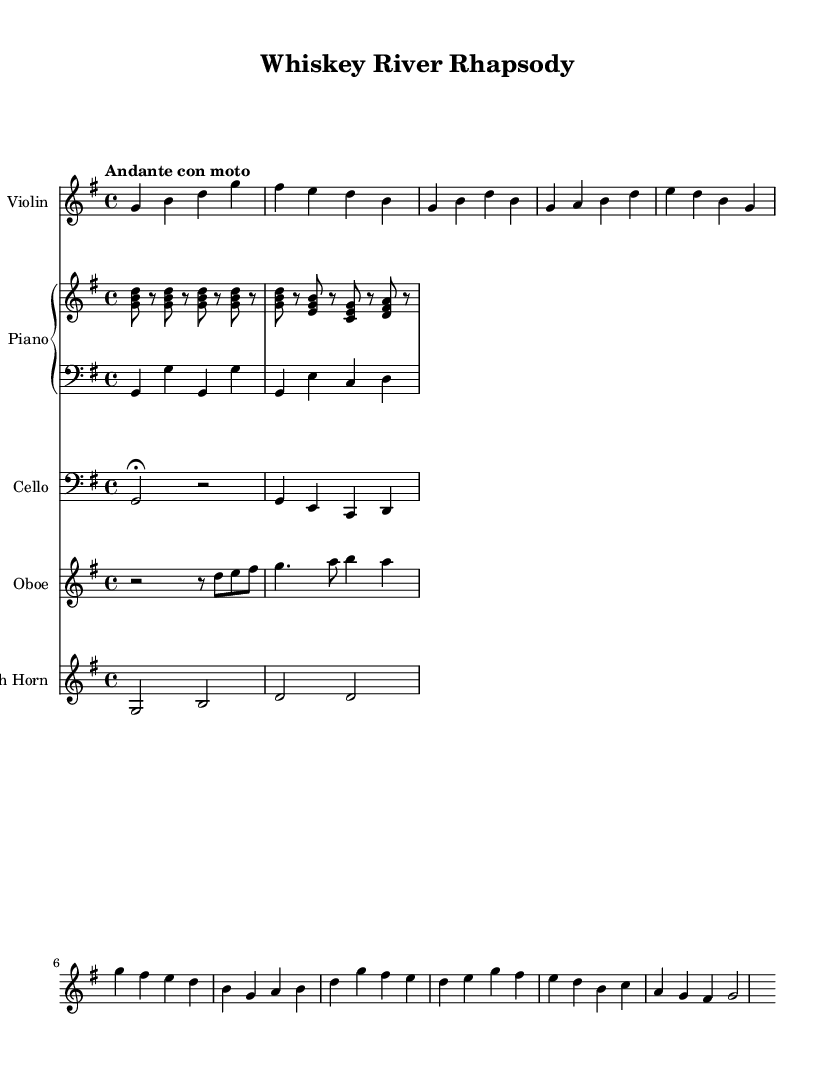What is the key signature of this music? The key signature is G major, which has one sharp (F#). This can be deduced by looking at the key signature indicator found at the beginning of the staff.
Answer: G major What is the time signature of the piece? The time signature is 4/4, indicated at the beginning of the score. This means there are four beats in each measure, and the quarter note receives one beat.
Answer: 4/4 What is the tempo marking for this piece? The tempo marking is "Andante con moto," suggesting a moderately slow tempo with some movement. This marking is located at the beginning of the score, right after the time signature.
Answer: Andante con moto How many instruments are featured in this arrangement? The score features five instruments: Violin, Piano, Cello, Oboe, and French Horn, as indicated by the instrument names at the start of each staff.
Answer: Five What type of musical form is being used in this piece? The piece exhibits a verse-chorus structure typical of traditional country songs. This can be inferred from the distinction in musical lines labeled as "Verse 1" and "Chorus" within the score.
Answer: Verse-Chorus Which instrument plays the counter melody? The Oboe plays the counter melody, as indicated by the content and staff labeling in the score. The Oboe's line adds a complementary phrase that supports the main melody.
Answer: Oboe What is the texture of the music? The music features a homophonic texture, where the melody (violin) is supported by accompaniment (piano, cello, etc.), allowing the main tune to stand out while harmonies and rhythms provide support. This is a common characteristic in arrangements blending traditional and classical elements.
Answer: Homophonic 